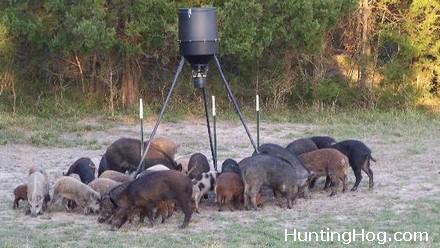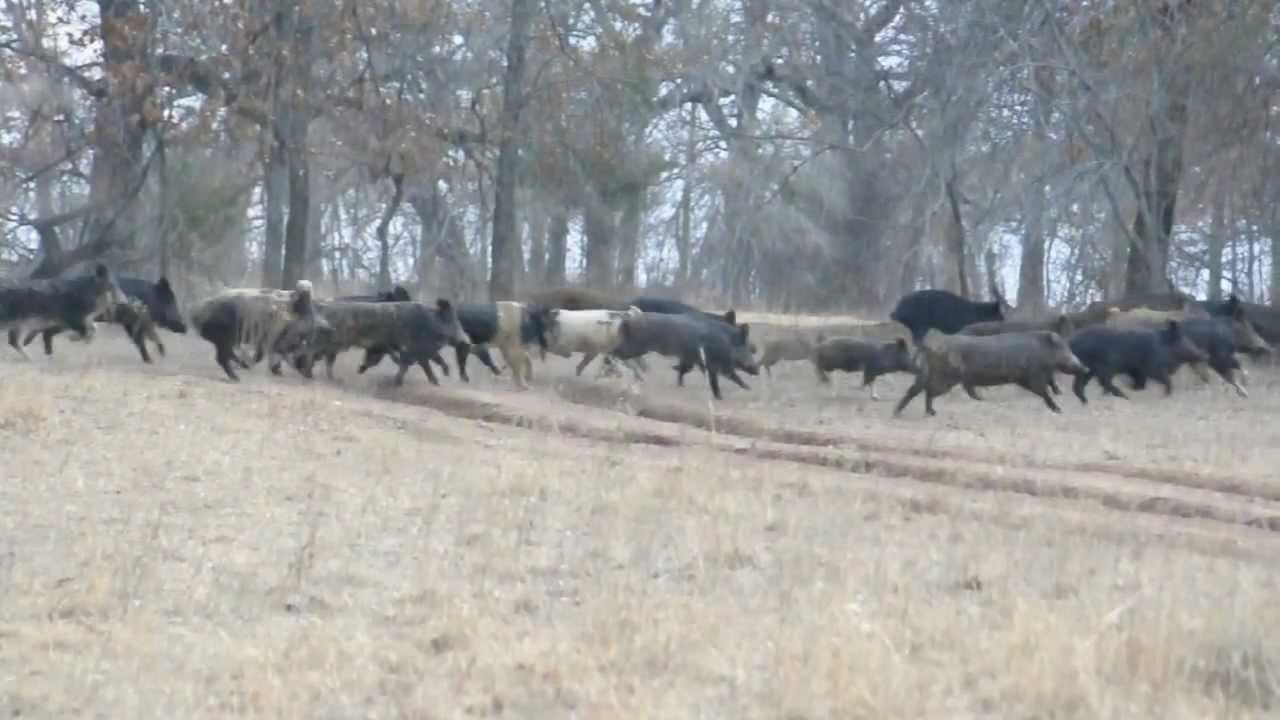The first image is the image on the left, the second image is the image on the right. Evaluate the accuracy of this statement regarding the images: "There are many wild boar hanging together in a pack near the woods". Is it true? Answer yes or no. Yes. The first image is the image on the left, the second image is the image on the right. Examine the images to the left and right. Is the description "Every picture has more than 6 pigs" accurate? Answer yes or no. Yes. 